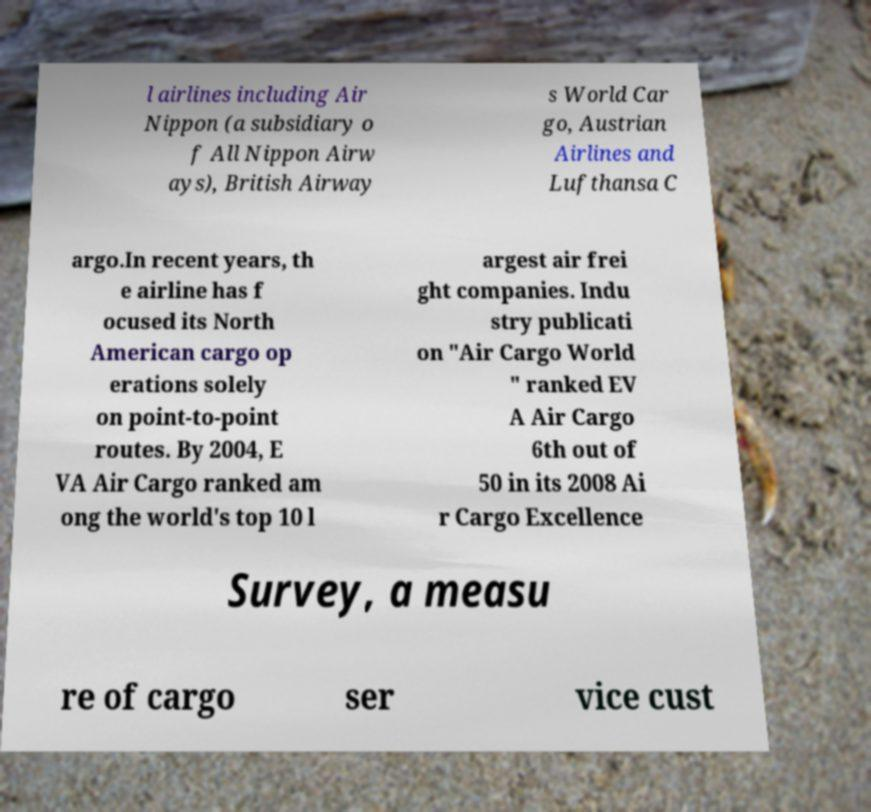Please identify and transcribe the text found in this image. l airlines including Air Nippon (a subsidiary o f All Nippon Airw ays), British Airway s World Car go, Austrian Airlines and Lufthansa C argo.In recent years, th e airline has f ocused its North American cargo op erations solely on point-to-point routes. By 2004, E VA Air Cargo ranked am ong the world's top 10 l argest air frei ght companies. Indu stry publicati on "Air Cargo World " ranked EV A Air Cargo 6th out of 50 in its 2008 Ai r Cargo Excellence Survey, a measu re of cargo ser vice cust 